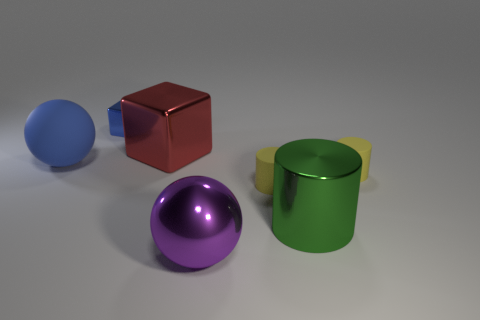Subtract all yellow matte cylinders. How many cylinders are left? 1 Add 2 small things. How many objects exist? 9 Subtract all yellow cylinders. How many cylinders are left? 1 Subtract all balls. How many objects are left? 5 Subtract all brown cylinders. How many red cubes are left? 1 Subtract all cyan objects. Subtract all cubes. How many objects are left? 5 Add 5 small cubes. How many small cubes are left? 6 Add 3 small yellow objects. How many small yellow objects exist? 5 Subtract 0 green spheres. How many objects are left? 7 Subtract 2 blocks. How many blocks are left? 0 